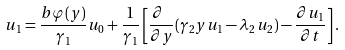Convert formula to latex. <formula><loc_0><loc_0><loc_500><loc_500>u _ { 1 } = \frac { b \varphi ( y ) } { \gamma _ { 1 } } u _ { 0 } + \frac { 1 } { \gamma _ { 1 } } \left [ \frac { \partial \ } { \partial y } ( \gamma _ { 2 } y u _ { 1 } - \lambda _ { 2 } u _ { 2 } ) - \frac { \partial u _ { 1 } } { \partial t } \right ] .</formula> 